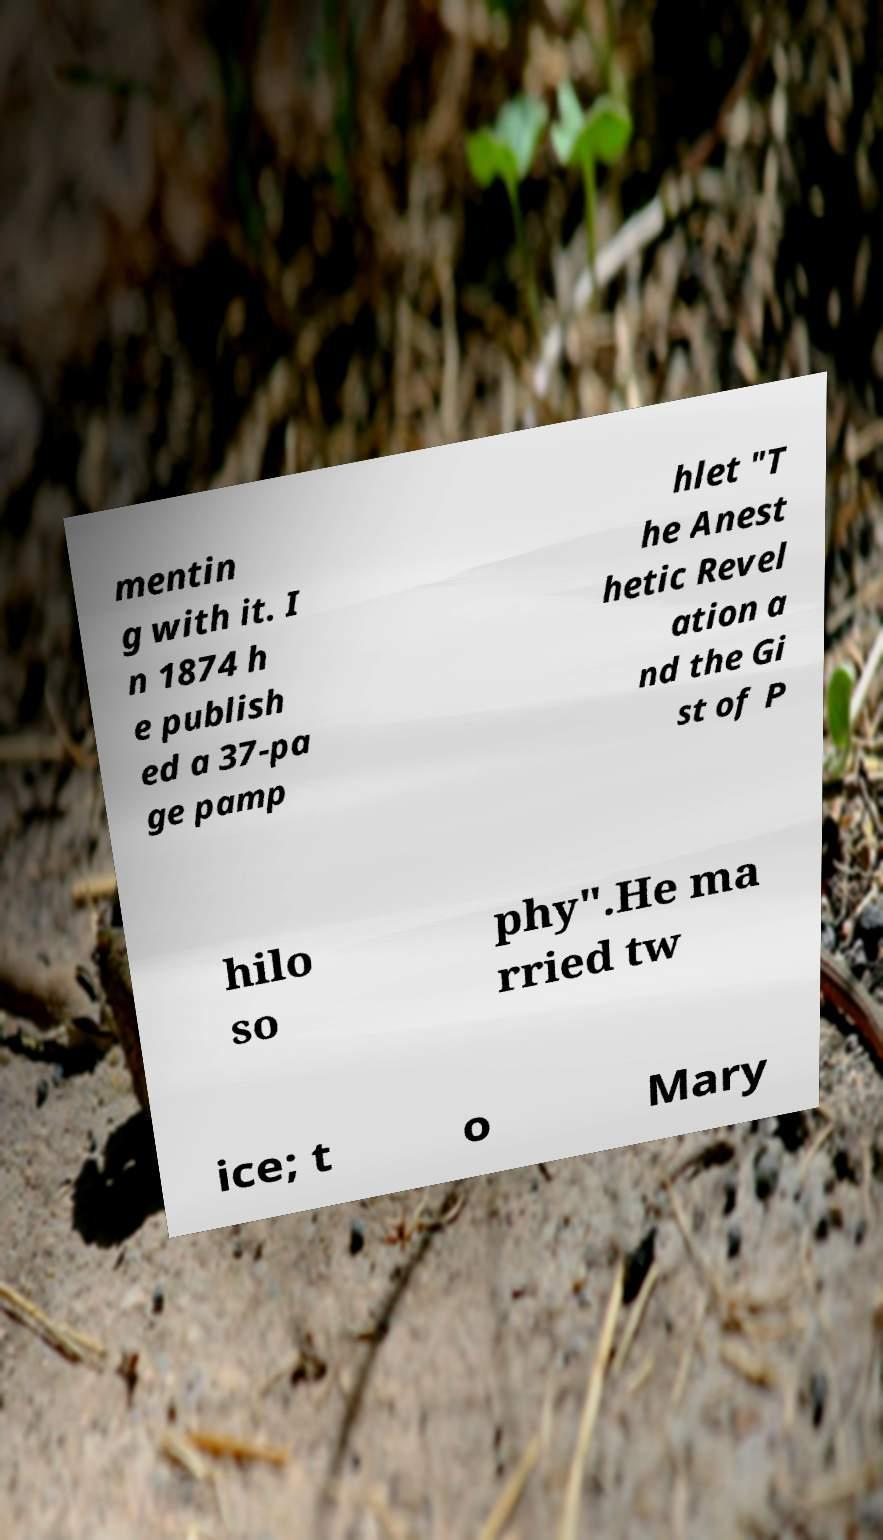Please identify and transcribe the text found in this image. mentin g with it. I n 1874 h e publish ed a 37-pa ge pamp hlet "T he Anest hetic Revel ation a nd the Gi st of P hilo so phy".He ma rried tw ice; t o Mary 